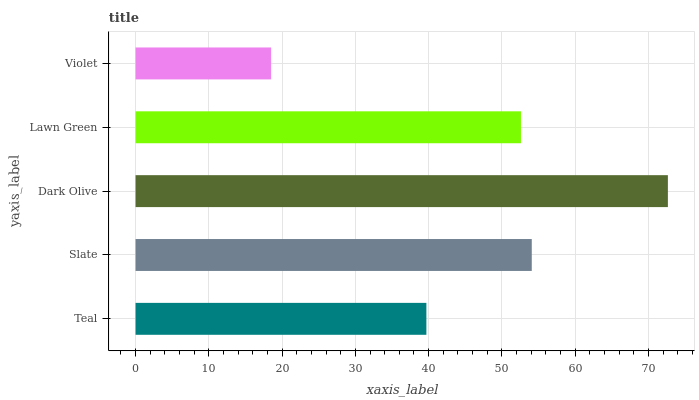Is Violet the minimum?
Answer yes or no. Yes. Is Dark Olive the maximum?
Answer yes or no. Yes. Is Slate the minimum?
Answer yes or no. No. Is Slate the maximum?
Answer yes or no. No. Is Slate greater than Teal?
Answer yes or no. Yes. Is Teal less than Slate?
Answer yes or no. Yes. Is Teal greater than Slate?
Answer yes or no. No. Is Slate less than Teal?
Answer yes or no. No. Is Lawn Green the high median?
Answer yes or no. Yes. Is Lawn Green the low median?
Answer yes or no. Yes. Is Slate the high median?
Answer yes or no. No. Is Teal the low median?
Answer yes or no. No. 